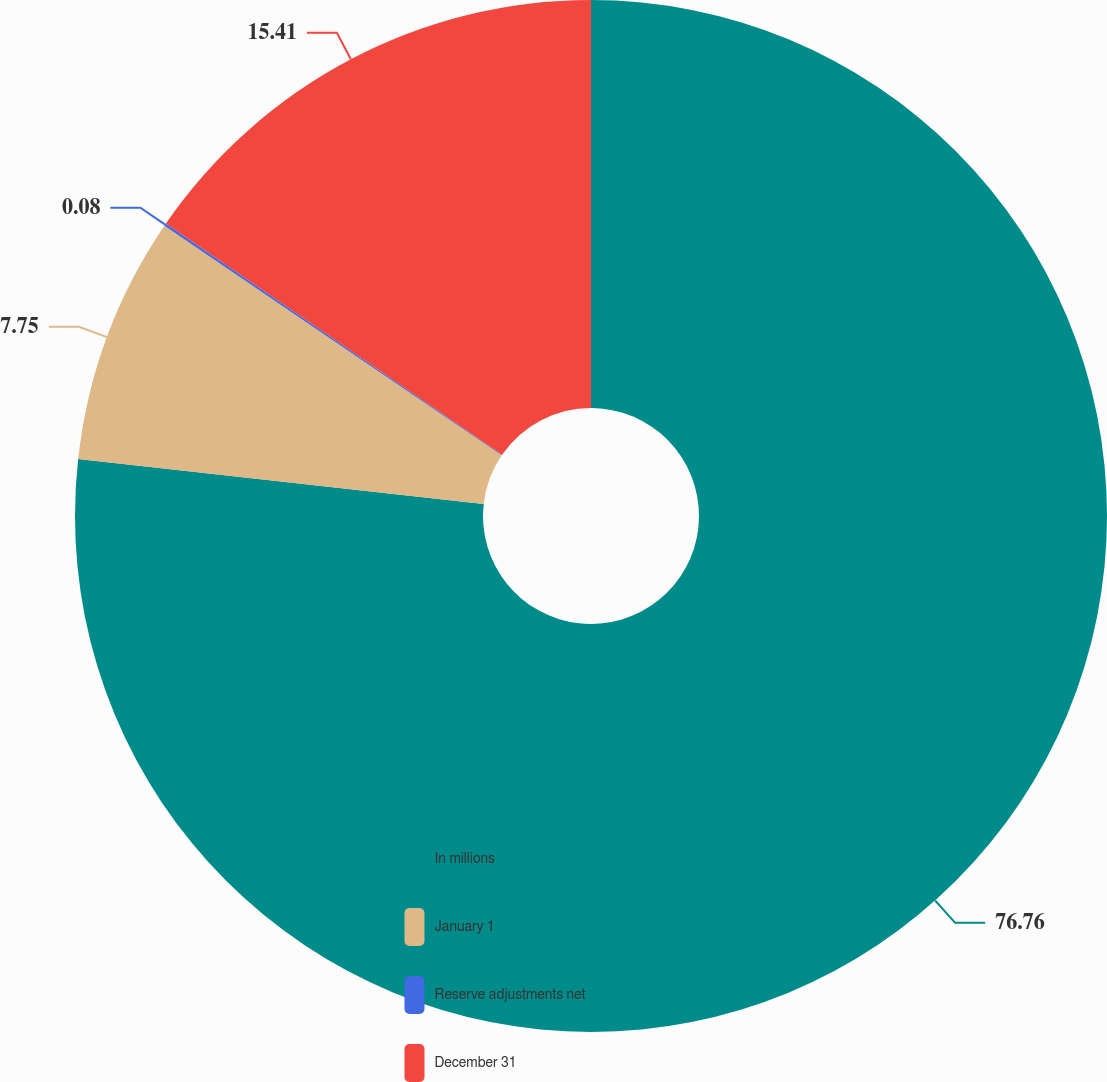Convert chart. <chart><loc_0><loc_0><loc_500><loc_500><pie_chart><fcel>In millions<fcel>January 1<fcel>Reserve adjustments net<fcel>December 31<nl><fcel>76.76%<fcel>7.75%<fcel>0.08%<fcel>15.41%<nl></chart> 